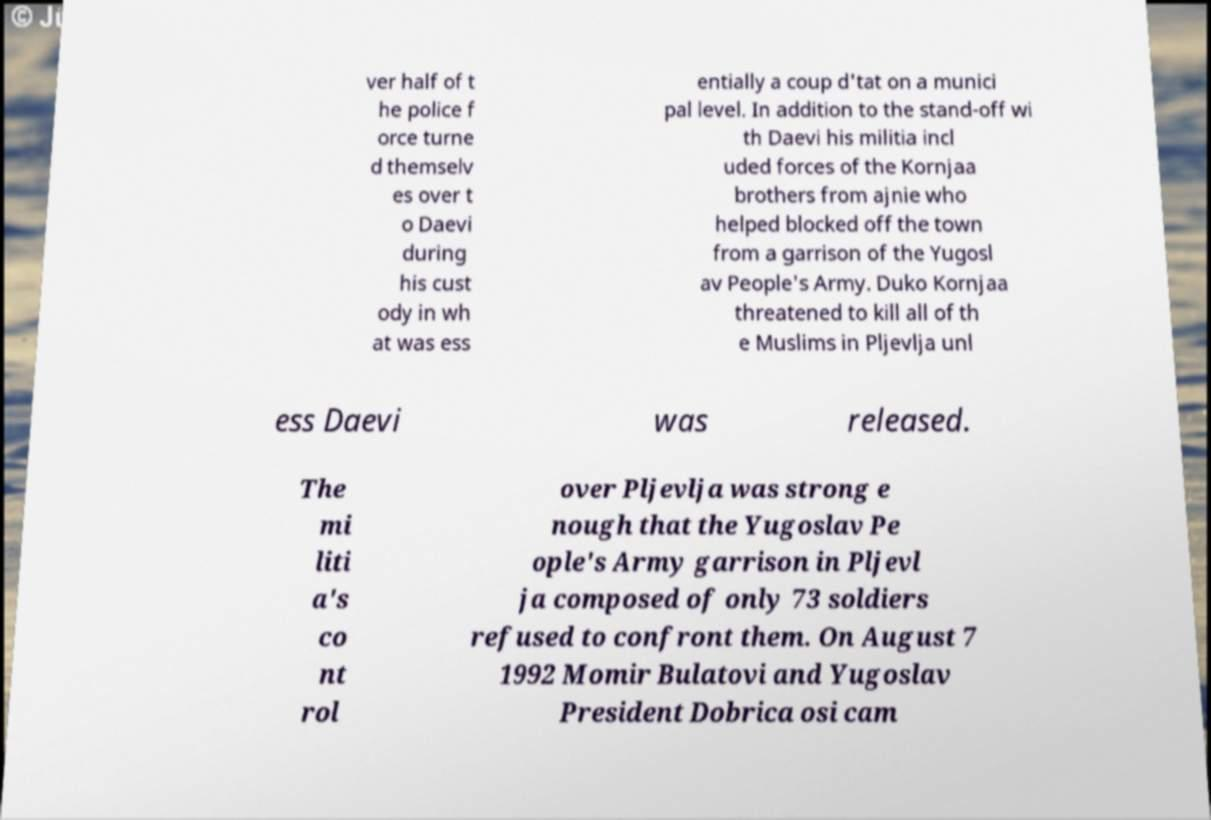What messages or text are displayed in this image? I need them in a readable, typed format. ver half of t he police f orce turne d themselv es over t o Daevi during his cust ody in wh at was ess entially a coup d'tat on a munici pal level. In addition to the stand-off wi th Daevi his militia incl uded forces of the Kornjaa brothers from ajnie who helped blocked off the town from a garrison of the Yugosl av People's Army. Duko Kornjaa threatened to kill all of th e Muslims in Pljevlja unl ess Daevi was released. The mi liti a's co nt rol over Pljevlja was strong e nough that the Yugoslav Pe ople's Army garrison in Pljevl ja composed of only 73 soldiers refused to confront them. On August 7 1992 Momir Bulatovi and Yugoslav President Dobrica osi cam 